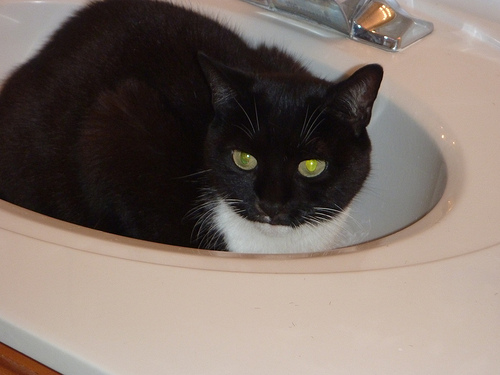How many cats are seen? There is one cat seen in the image, comfortably nestled in a bathroom sink. Its striking black and white fur and bright green eyes are quite captivating. 